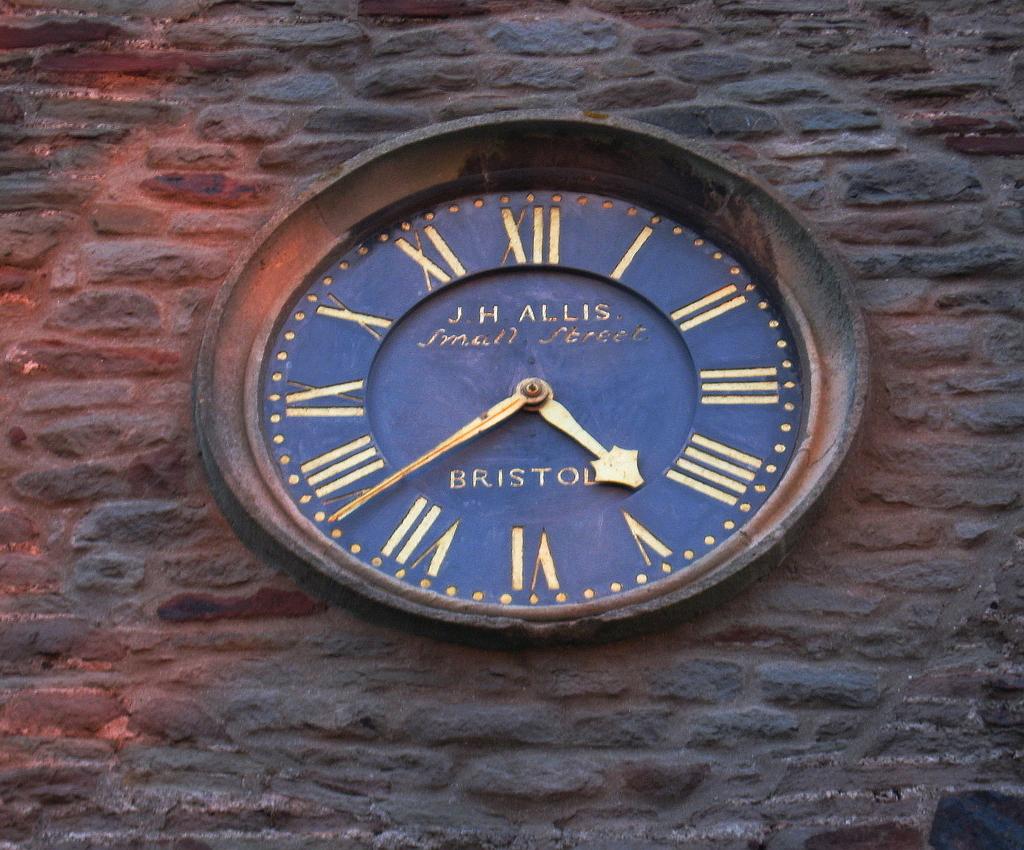What is the city name about the 6?
Ensure brevity in your answer.  Bristol. What is the bottom word on the clock?
Give a very brief answer. Bristol. 